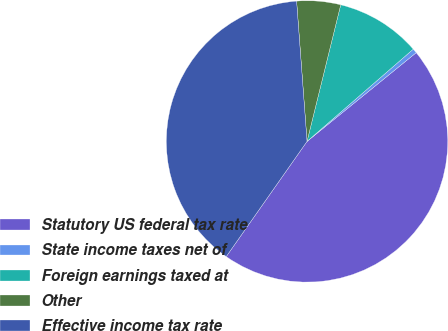<chart> <loc_0><loc_0><loc_500><loc_500><pie_chart><fcel>Statutory US federal tax rate<fcel>State income taxes net of<fcel>Foreign earnings taxed at<fcel>Other<fcel>Effective income tax rate<nl><fcel>45.6%<fcel>0.52%<fcel>9.77%<fcel>5.03%<fcel>39.08%<nl></chart> 